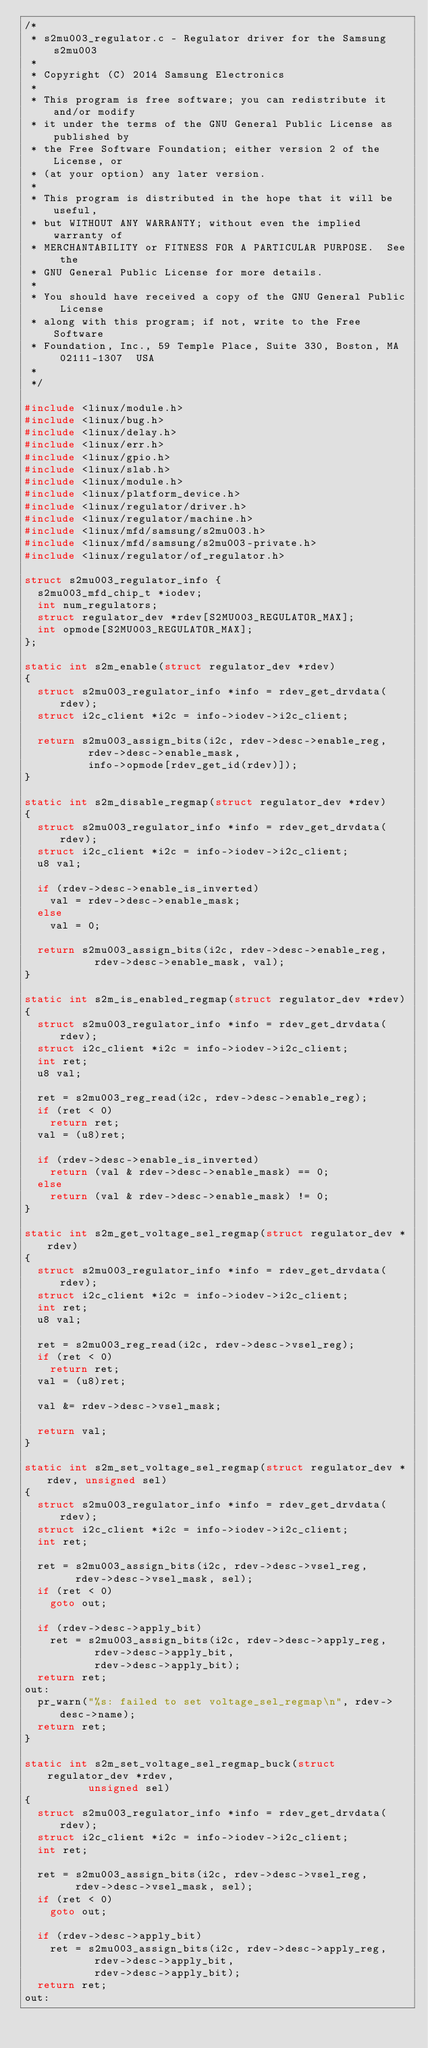Convert code to text. <code><loc_0><loc_0><loc_500><loc_500><_C_>/*
 * s2mu003_regulator.c - Regulator driver for the Samsung s2mu003
 *
 * Copyright (C) 2014 Samsung Electronics
 *
 * This program is free software; you can redistribute it and/or modify
 * it under the terms of the GNU General Public License as published by
 * the Free Software Foundation; either version 2 of the License, or
 * (at your option) any later version.
 *
 * This program is distributed in the hope that it will be useful,
 * but WITHOUT ANY WARRANTY; without even the implied warranty of
 * MERCHANTABILITY or FITNESS FOR A PARTICULAR PURPOSE.  See the
 * GNU General Public License for more details.
 *
 * You should have received a copy of the GNU General Public License
 * along with this program; if not, write to the Free Software
 * Foundation, Inc., 59 Temple Place, Suite 330, Boston, MA  02111-1307  USA
 *
 */

#include <linux/module.h>
#include <linux/bug.h>
#include <linux/delay.h>
#include <linux/err.h>
#include <linux/gpio.h>
#include <linux/slab.h>
#include <linux/module.h>
#include <linux/platform_device.h>
#include <linux/regulator/driver.h>
#include <linux/regulator/machine.h>
#include <linux/mfd/samsung/s2mu003.h>
#include <linux/mfd/samsung/s2mu003-private.h>
#include <linux/regulator/of_regulator.h>

struct s2mu003_regulator_info {
	s2mu003_mfd_chip_t *iodev;
	int num_regulators;
	struct regulator_dev *rdev[S2MU003_REGULATOR_MAX];
	int opmode[S2MU003_REGULATOR_MAX];
};

static int s2m_enable(struct regulator_dev *rdev)
{
	struct s2mu003_regulator_info *info = rdev_get_drvdata(rdev);
	struct i2c_client *i2c = info->iodev->i2c_client;

	return s2mu003_assign_bits(i2c, rdev->desc->enable_reg,
				  rdev->desc->enable_mask,
				  info->opmode[rdev_get_id(rdev)]);
}

static int s2m_disable_regmap(struct regulator_dev *rdev)
{
	struct s2mu003_regulator_info *info = rdev_get_drvdata(rdev);
	struct i2c_client *i2c = info->iodev->i2c_client;
	u8 val;

	if (rdev->desc->enable_is_inverted)
		val = rdev->desc->enable_mask;
	else
		val = 0;

	return s2mu003_assign_bits(i2c, rdev->desc->enable_reg,
				   rdev->desc->enable_mask, val);
}

static int s2m_is_enabled_regmap(struct regulator_dev *rdev)
{
	struct s2mu003_regulator_info *info = rdev_get_drvdata(rdev);
	struct i2c_client *i2c = info->iodev->i2c_client;
	int ret;
	u8 val;

	ret = s2mu003_reg_read(i2c, rdev->desc->enable_reg);
	if (ret < 0)
		return ret;
	val = (u8)ret;

	if (rdev->desc->enable_is_inverted)
		return (val & rdev->desc->enable_mask) == 0;
	else
		return (val & rdev->desc->enable_mask) != 0;
}

static int s2m_get_voltage_sel_regmap(struct regulator_dev *rdev)
{
	struct s2mu003_regulator_info *info = rdev_get_drvdata(rdev);
	struct i2c_client *i2c = info->iodev->i2c_client;
	int ret;
	u8 val;

	ret = s2mu003_reg_read(i2c, rdev->desc->vsel_reg);
	if (ret < 0)
		return ret;
	val = (u8)ret;

	val &= rdev->desc->vsel_mask;

	return val;
}

static int s2m_set_voltage_sel_regmap(struct regulator_dev *rdev, unsigned sel)
{
	struct s2mu003_regulator_info *info = rdev_get_drvdata(rdev);
	struct i2c_client *i2c = info->iodev->i2c_client;
	int ret;

	ret = s2mu003_assign_bits(i2c, rdev->desc->vsel_reg,
				rdev->desc->vsel_mask, sel);
	if (ret < 0)
		goto out;

	if (rdev->desc->apply_bit)
		ret = s2mu003_assign_bits(i2c, rdev->desc->apply_reg,
					 rdev->desc->apply_bit,
					 rdev->desc->apply_bit);
	return ret;
out:
	pr_warn("%s: failed to set voltage_sel_regmap\n", rdev->desc->name);
	return ret;
}

static int s2m_set_voltage_sel_regmap_buck(struct regulator_dev *rdev,
					unsigned sel)
{
	struct s2mu003_regulator_info *info = rdev_get_drvdata(rdev);
	struct i2c_client *i2c = info->iodev->i2c_client;
	int ret;

	ret = s2mu003_assign_bits(i2c, rdev->desc->vsel_reg,
				rdev->desc->vsel_mask, sel);
	if (ret < 0)
		goto out;

	if (rdev->desc->apply_bit)
		ret = s2mu003_assign_bits(i2c, rdev->desc->apply_reg,
					 rdev->desc->apply_bit,
					 rdev->desc->apply_bit);
	return ret;
out:</code> 